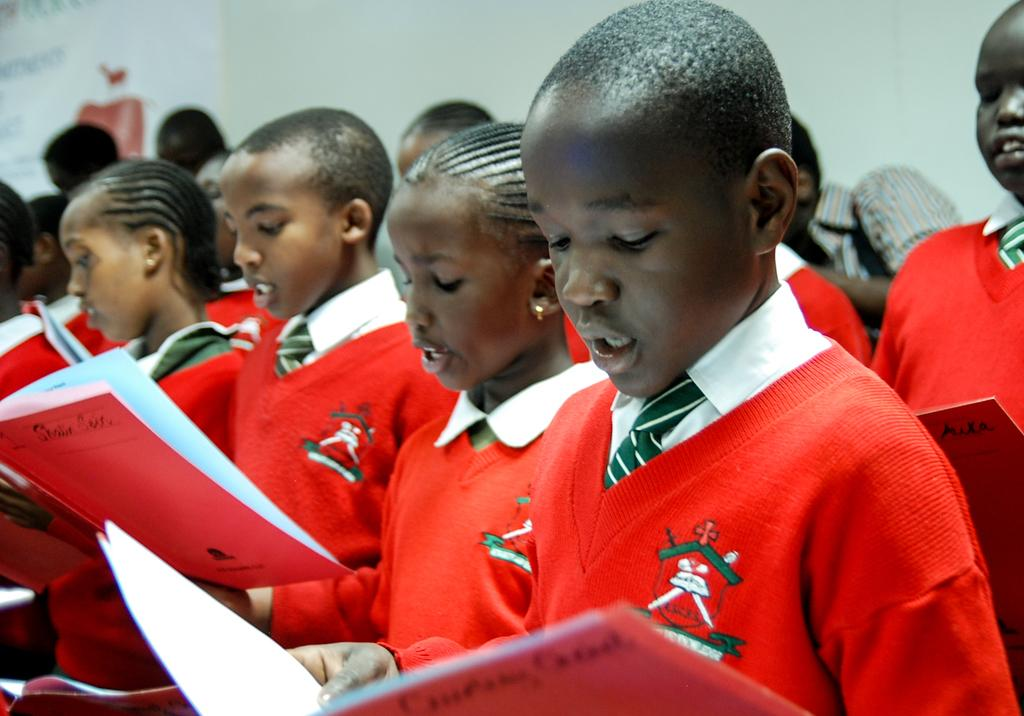Who is present in the image? There are kids in the image. What are the kids holding in the image? The kids are holding books. What can be seen in the background of the image? There is a wall and a poster in the background of the image. What type of substance is the kids using to climb the wall in the image? There is no substance or climbing activity present in the image; the kids are holding books and there is a wall in the background. 